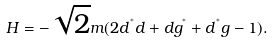<formula> <loc_0><loc_0><loc_500><loc_500>H = - \sqrt { 2 } m ( 2 d ^ { ^ { * } } d + d g ^ { ^ { * } } + d ^ { ^ { * } } g - 1 ) .</formula> 